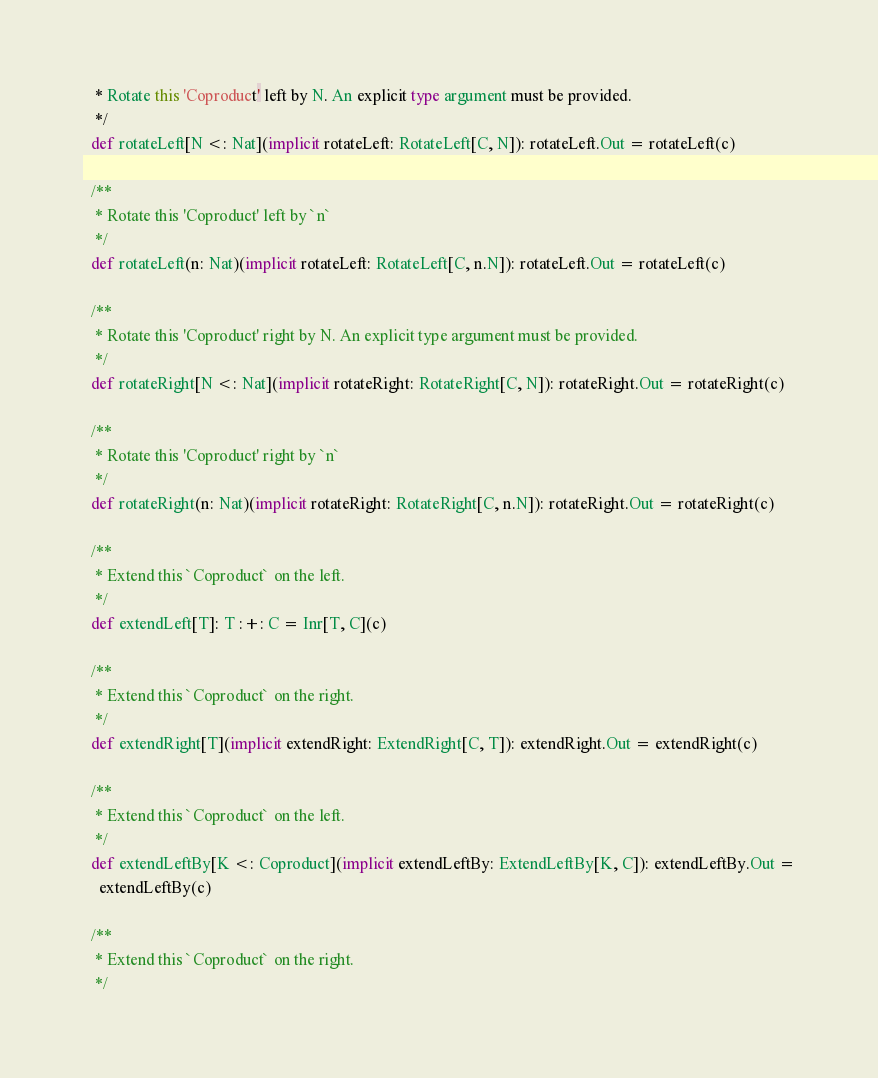Convert code to text. <code><loc_0><loc_0><loc_500><loc_500><_Scala_>   * Rotate this 'Coproduct' left by N. An explicit type argument must be provided.
   */
  def rotateLeft[N <: Nat](implicit rotateLeft: RotateLeft[C, N]): rotateLeft.Out = rotateLeft(c)

  /**
   * Rotate this 'Coproduct' left by `n`
   */
  def rotateLeft(n: Nat)(implicit rotateLeft: RotateLeft[C, n.N]): rotateLeft.Out = rotateLeft(c)

  /**
   * Rotate this 'Coproduct' right by N. An explicit type argument must be provided.
   */
  def rotateRight[N <: Nat](implicit rotateRight: RotateRight[C, N]): rotateRight.Out = rotateRight(c)

  /**
   * Rotate this 'Coproduct' right by `n`
   */
  def rotateRight(n: Nat)(implicit rotateRight: RotateRight[C, n.N]): rotateRight.Out = rotateRight(c)

  /**
   * Extend this `Coproduct` on the left.
   */
  def extendLeft[T]: T :+: C = Inr[T, C](c)

  /**
   * Extend this `Coproduct` on the right.
   */
  def extendRight[T](implicit extendRight: ExtendRight[C, T]): extendRight.Out = extendRight(c)

  /**
   * Extend this `Coproduct` on the left.
   */
  def extendLeftBy[K <: Coproduct](implicit extendLeftBy: ExtendLeftBy[K, C]): extendLeftBy.Out =
    extendLeftBy(c)

  /**
   * Extend this `Coproduct` on the right.
   */</code> 